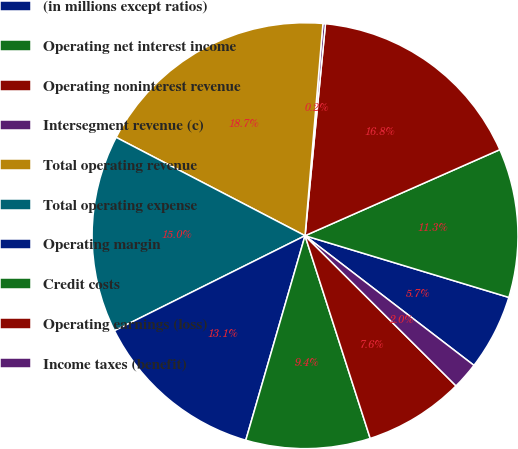Convert chart to OTSL. <chart><loc_0><loc_0><loc_500><loc_500><pie_chart><fcel>(in millions except ratios)<fcel>Operating net interest income<fcel>Operating noninterest revenue<fcel>Intersegment revenue (c)<fcel>Total operating revenue<fcel>Total operating expense<fcel>Operating margin<fcel>Credit costs<fcel>Operating earnings (loss)<fcel>Income taxes (benefit)<nl><fcel>5.74%<fcel>11.3%<fcel>16.85%<fcel>0.19%<fcel>18.7%<fcel>15.0%<fcel>13.15%<fcel>9.44%<fcel>7.59%<fcel>2.04%<nl></chart> 